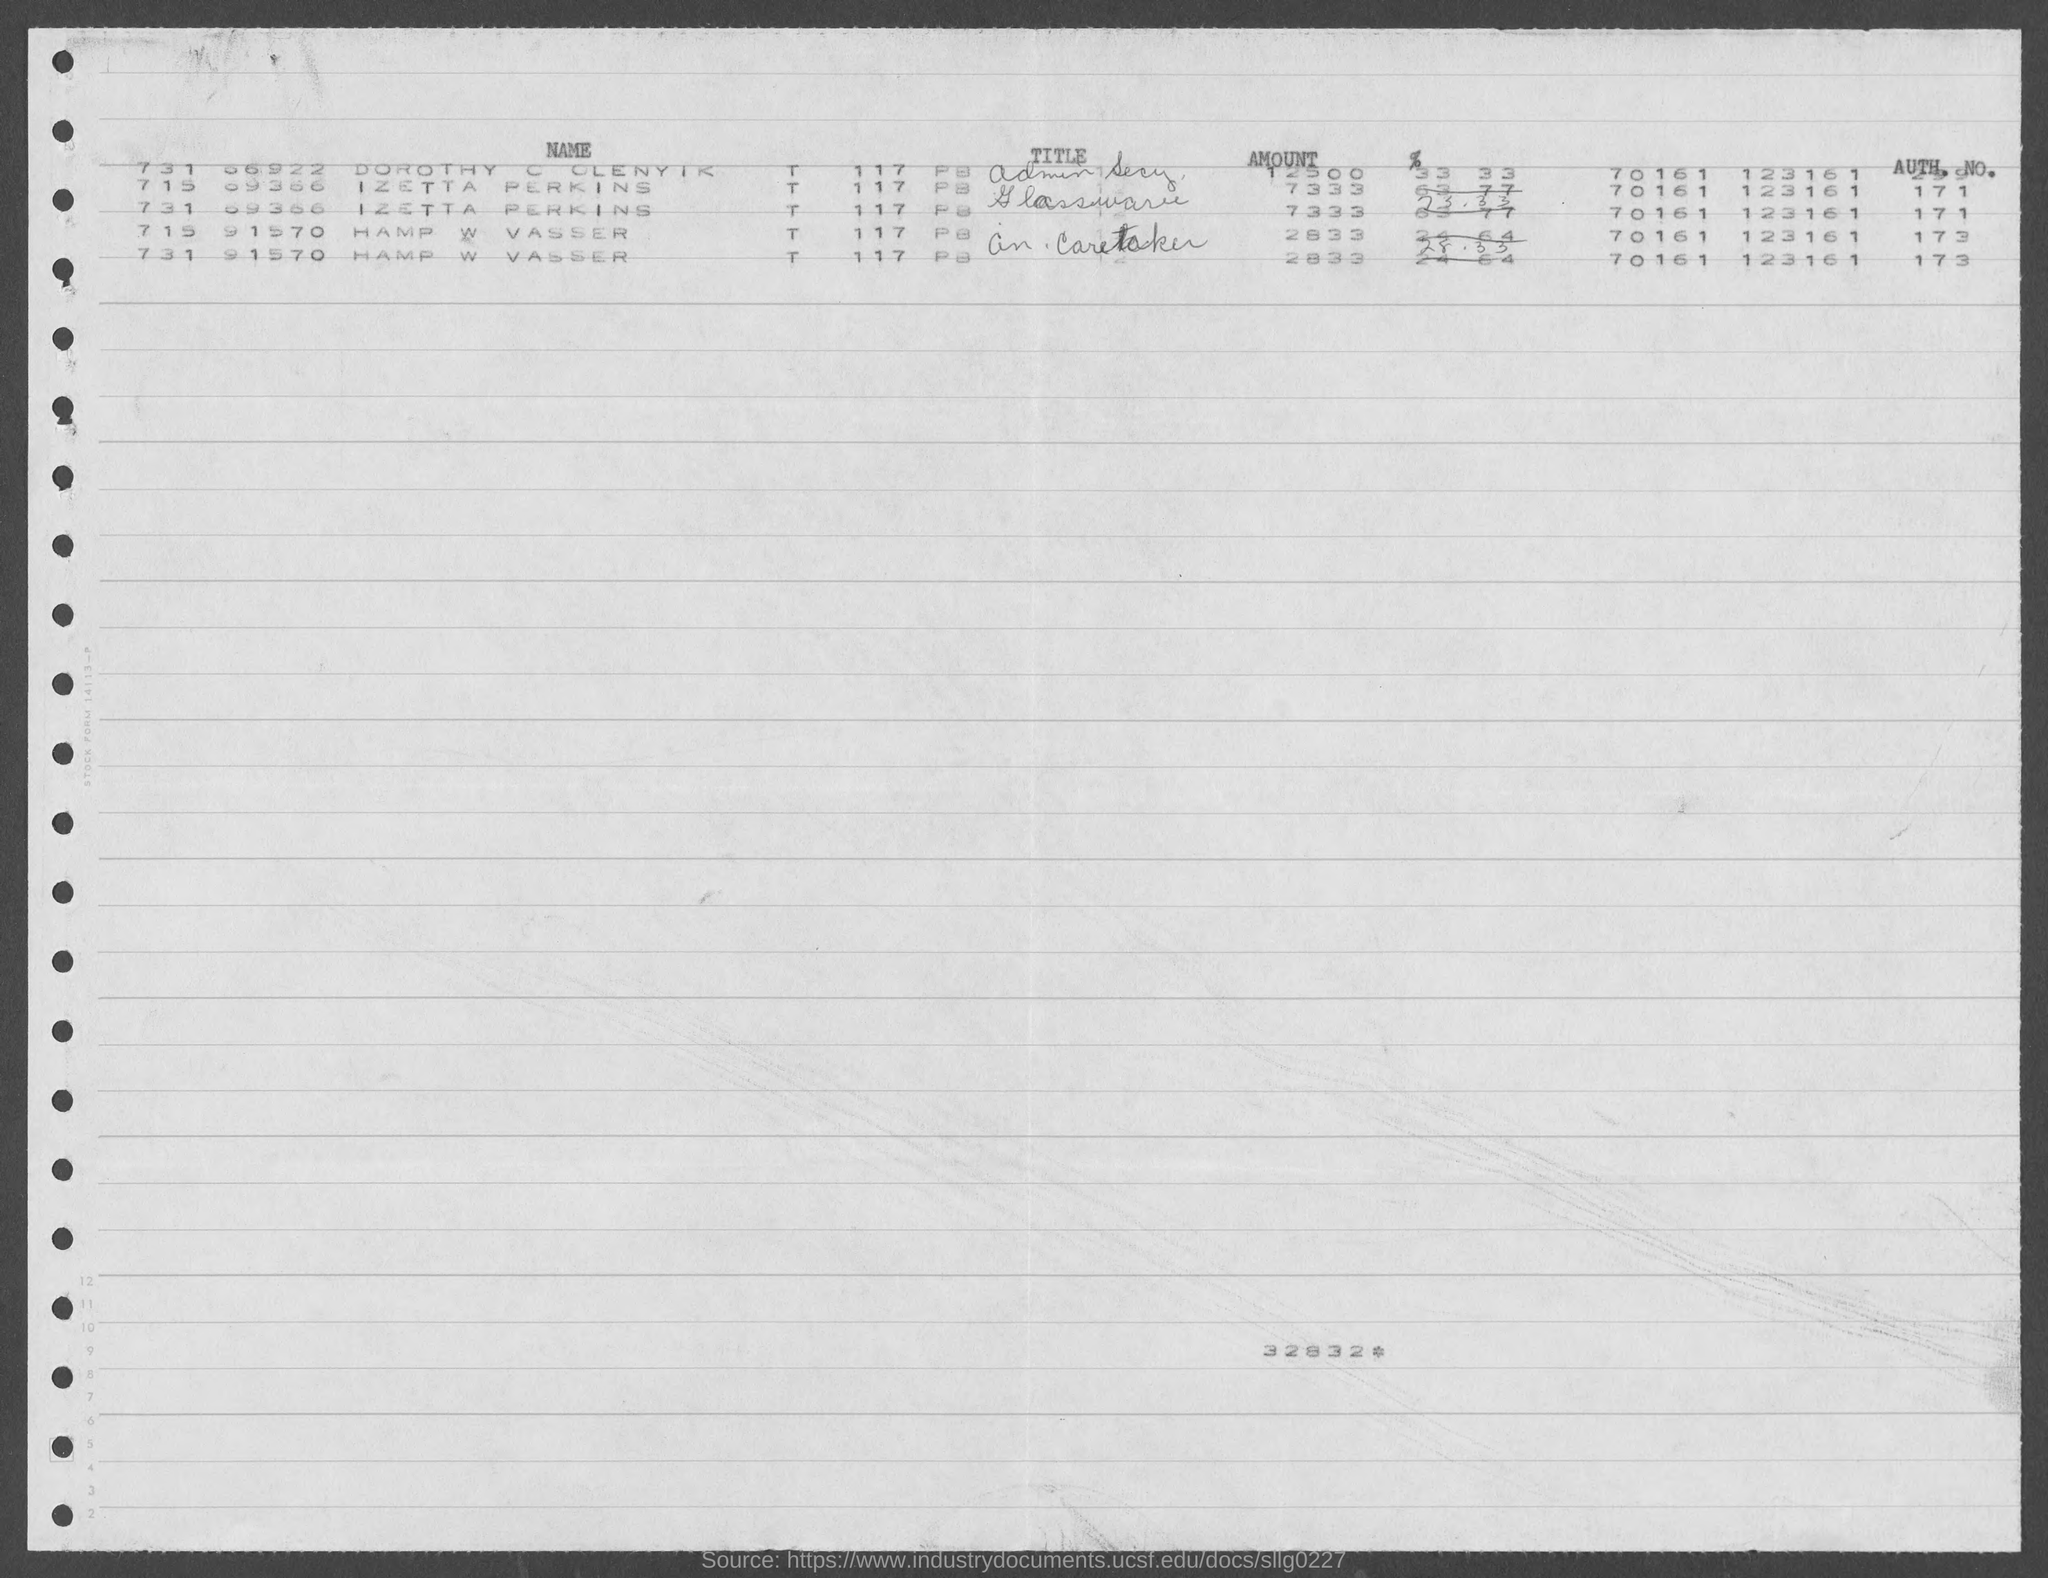What is the number at the bottom of the document?
Provide a succinct answer. 32832. What is the authorized number of Hamp W Vasser?
Offer a terse response. 173. What is the authorized number of Izetta Perkins?
Your answer should be compact. 171. What is the amount of Izetta Perkins?
Offer a very short reply. 7333. What is the amount of Hamp W Vasser?
Give a very brief answer. 2833. 